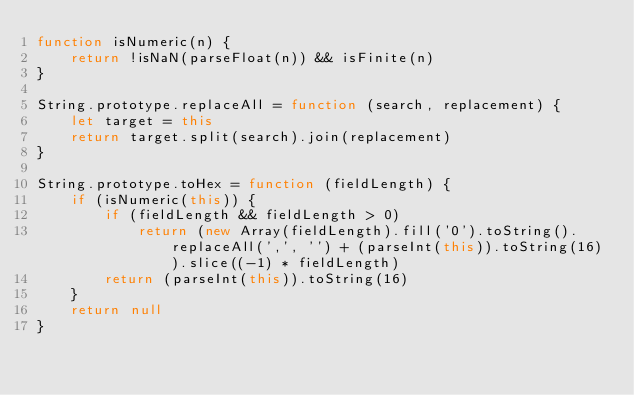Convert code to text. <code><loc_0><loc_0><loc_500><loc_500><_JavaScript_>function isNumeric(n) {
    return !isNaN(parseFloat(n)) && isFinite(n)
}

String.prototype.replaceAll = function (search, replacement) {
    let target = this
    return target.split(search).join(replacement)
}

String.prototype.toHex = function (fieldLength) {
    if (isNumeric(this)) {
        if (fieldLength && fieldLength > 0)
            return (new Array(fieldLength).fill('0').toString().replaceAll(',', '') + (parseInt(this)).toString(16)).slice((-1) * fieldLength)
        return (parseInt(this)).toString(16)
    }
    return null
}
</code> 